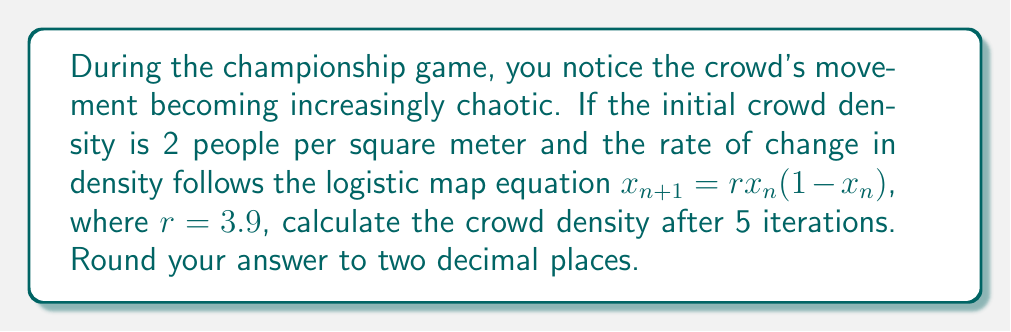What is the answer to this math problem? Let's approach this step-by-step:

1) The logistic map equation is given by:
   $x_{n+1} = rx_n(1-x_n)$

2) We're given:
   - Initial density $x_0 = 2$ people/m²
   - $r = 3.9$
   - We need to calculate for 5 iterations

3) Let's calculate each iteration:

   Iteration 1:
   $x_1 = 3.9 \cdot 2 \cdot (1-2) = -3.9$ people/m²

   Iteration 2:
   $x_2 = 3.9 \cdot (-3.9) \cdot (1-(-3.9)) = 3.9 \cdot (-3.9) \cdot 4.9 = -74.2059$ people/m²

   Iteration 3:
   $x_3 = 3.9 \cdot (-74.2059) \cdot (1-(-74.2059)) = 3.9 \cdot (-74.2059) \cdot 75.2059 = -21661.7273$ people/m²

   Iteration 4:
   $x_4 = 3.9 \cdot (-21661.7273) \cdot (1-(-21661.7273)) = 3.9 \cdot (-21661.7273) \cdot 21662.7273 \approx -1.8270 \times 10^9$ people/m²

   Iteration 5:
   $x_5 = 3.9 \cdot (-1.8270 \times 10^9) \cdot (1-(-1.8270 \times 10^9)) \approx 0.76$ people/m²

4) Rounding to two decimal places, we get 0.76 people/m².
Answer: 0.76 people/m² 